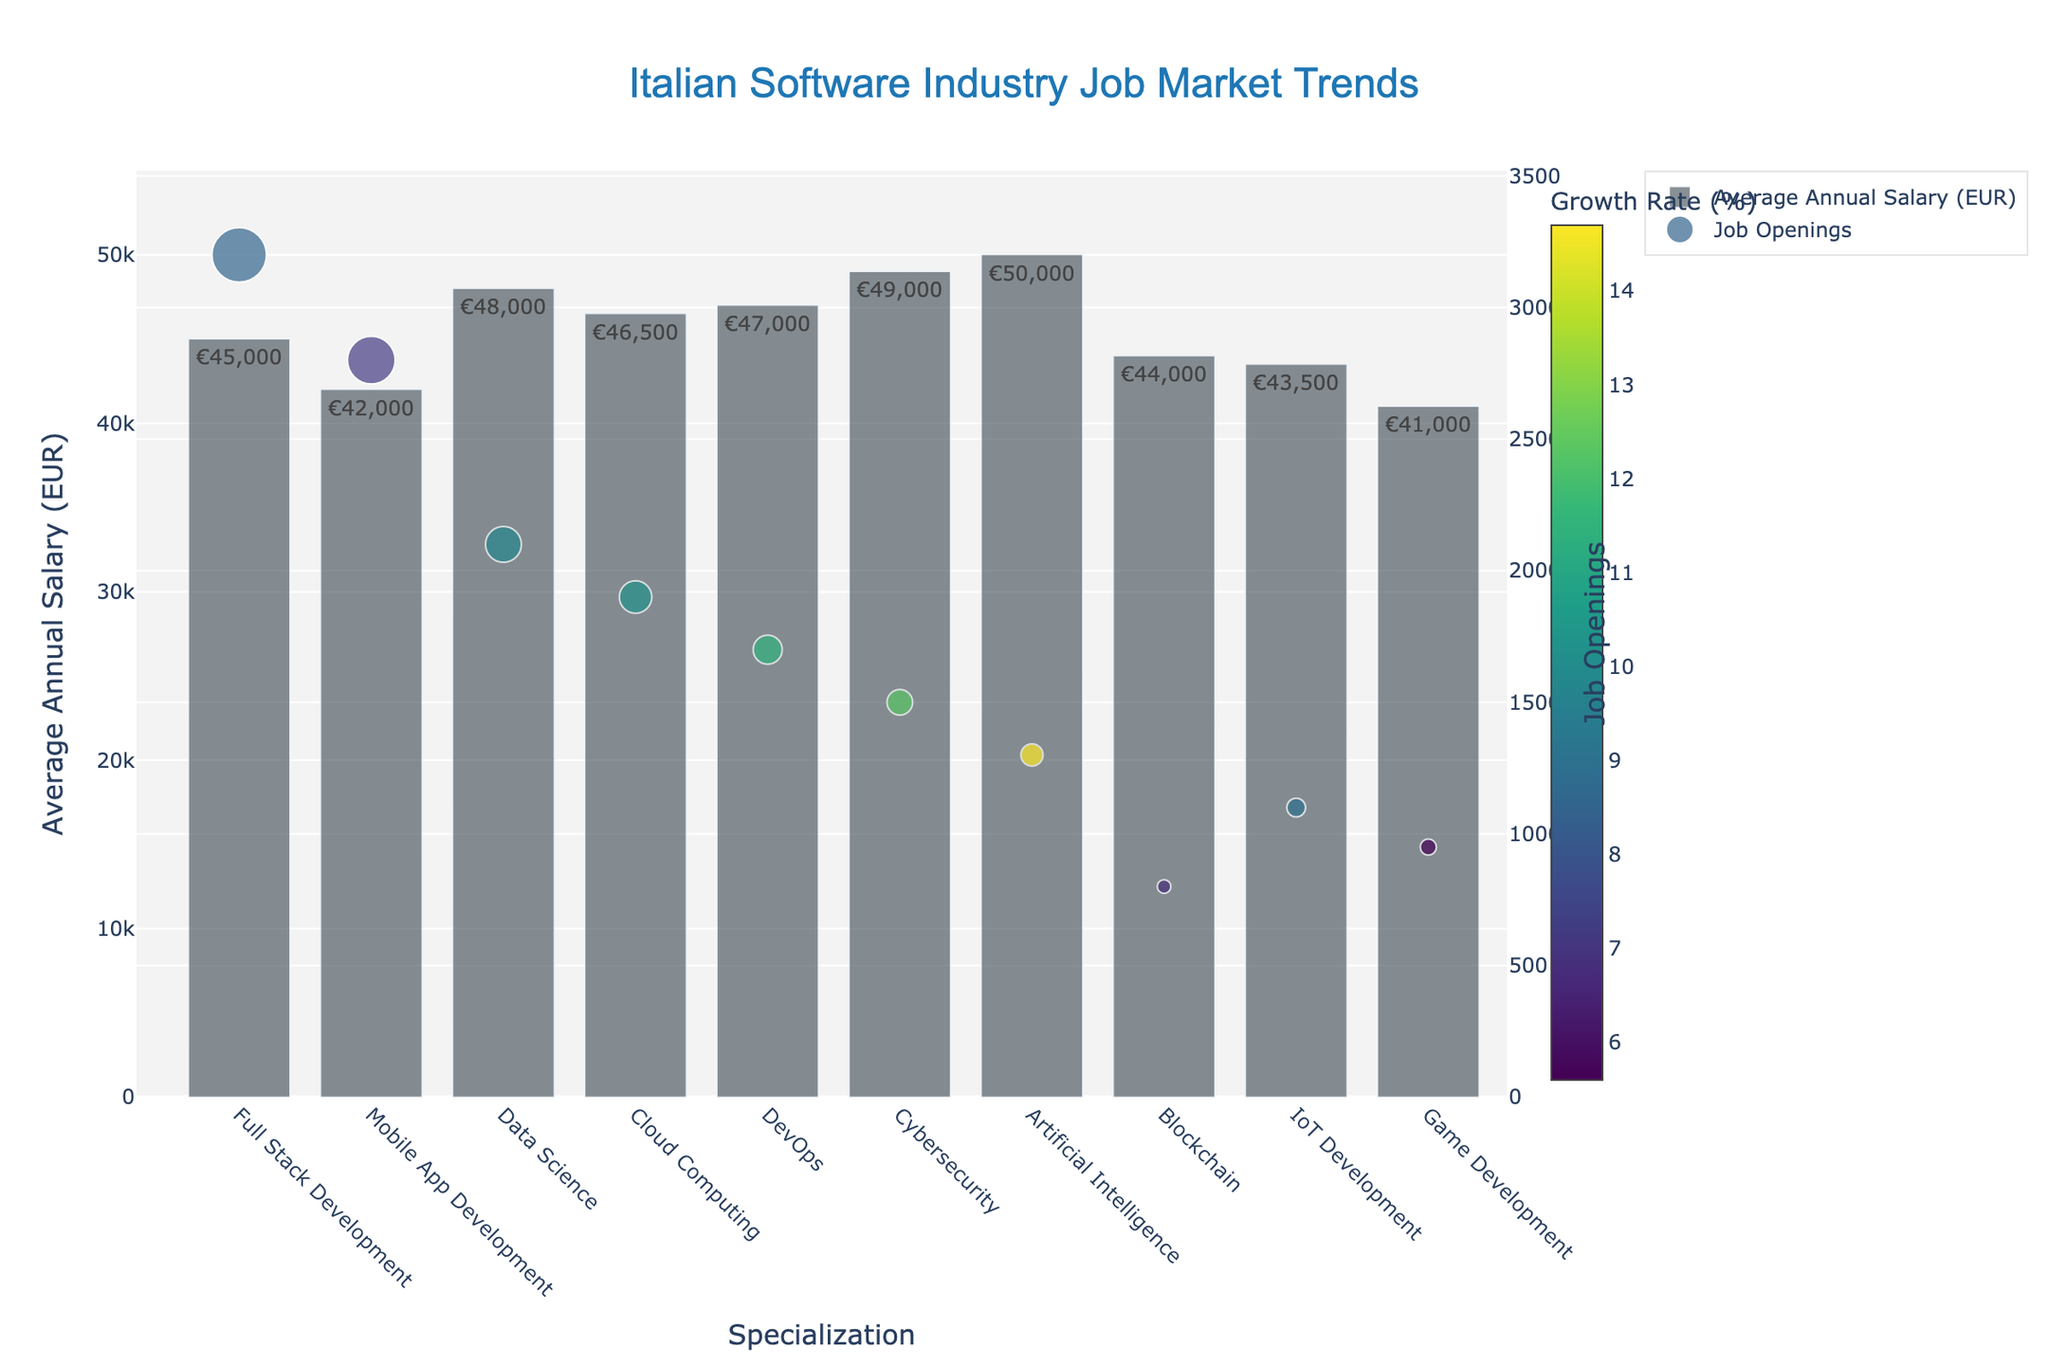Which specialization has the highest average annual salary? The bar representing the average annual salary for "Artificial Intelligence" is the tallest and has the largest label, indicating it has the highest salary.
Answer: Artificial Intelligence Which specialization has the highest growth rate? By observing the color gradient of the scatter points, the deepest color represents the highest growth rate, which is seen in the point for "Artificial Intelligence".
Answer: Artificial Intelligence What is the sum of the job openings for Full Stack Development and Mobile App Development? Full Stack Development has 3200 job openings, and Mobile App Development has 2800. Summing these gives 3200 + 2800 = 6000.
Answer: 6000 Which specialization has both a high average salary and high growth rate? "Artificial Intelligence" stands out with the highest salary bar and the deepest color in scatter points, indicating high growth rate.
Answer: Artificial Intelligence What is the average annual salary for the specialization with the lowest number of job openings? The scatter plot shows "Blockchain" has the least number of job openings. The bar for "Blockchain" shows an average salary of €44,000.
Answer: €44,000 How does the average salary for DevOps compare to Cloud Computing? The heights of the bars for DevOps (€47,000) and Cloud Computing (€46,500) are visually close, with DevOps being slightly taller.
Answer: DevOps is higher What is the difference in job openings between IoT Development and Game Development? IoT Development has 1100 job openings, while Game Development has 950. The difference is 1100 - 950 = 150.
Answer: 150 Which specialization has the lowest growth rate and what is its average annual salary? The least saturated scatter point represents the lowest growth, which is in "Game Development". Its bar shows an average salary of €41,000.
Answer: €41,000 What is the total average annual salary combining DevOps and Cybersecurity? DevOps has €47,000 and Cybersecurity has €49,000. Total is calculated as 47,000 + 49,000 = 96,000.
Answer: €96,000 